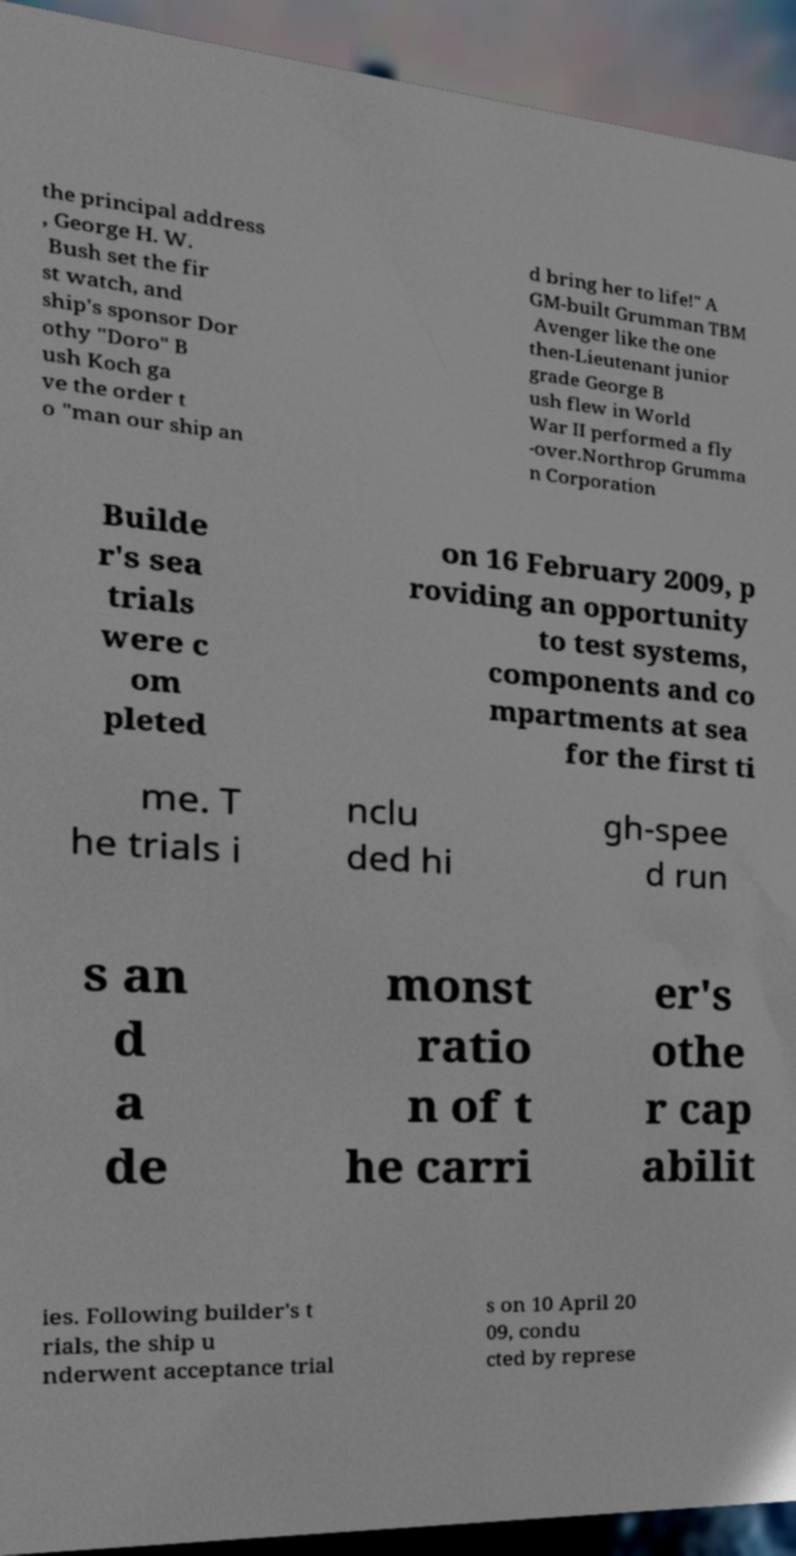Please identify and transcribe the text found in this image. the principal address , George H. W. Bush set the fir st watch, and ship's sponsor Dor othy "Doro" B ush Koch ga ve the order t o "man our ship an d bring her to life!" A GM-built Grumman TBM Avenger like the one then-Lieutenant junior grade George B ush flew in World War II performed a fly -over.Northrop Grumma n Corporation Builde r's sea trials were c om pleted on 16 February 2009, p roviding an opportunity to test systems, components and co mpartments at sea for the first ti me. T he trials i nclu ded hi gh-spee d run s an d a de monst ratio n of t he carri er's othe r cap abilit ies. Following builder's t rials, the ship u nderwent acceptance trial s on 10 April 20 09, condu cted by represe 